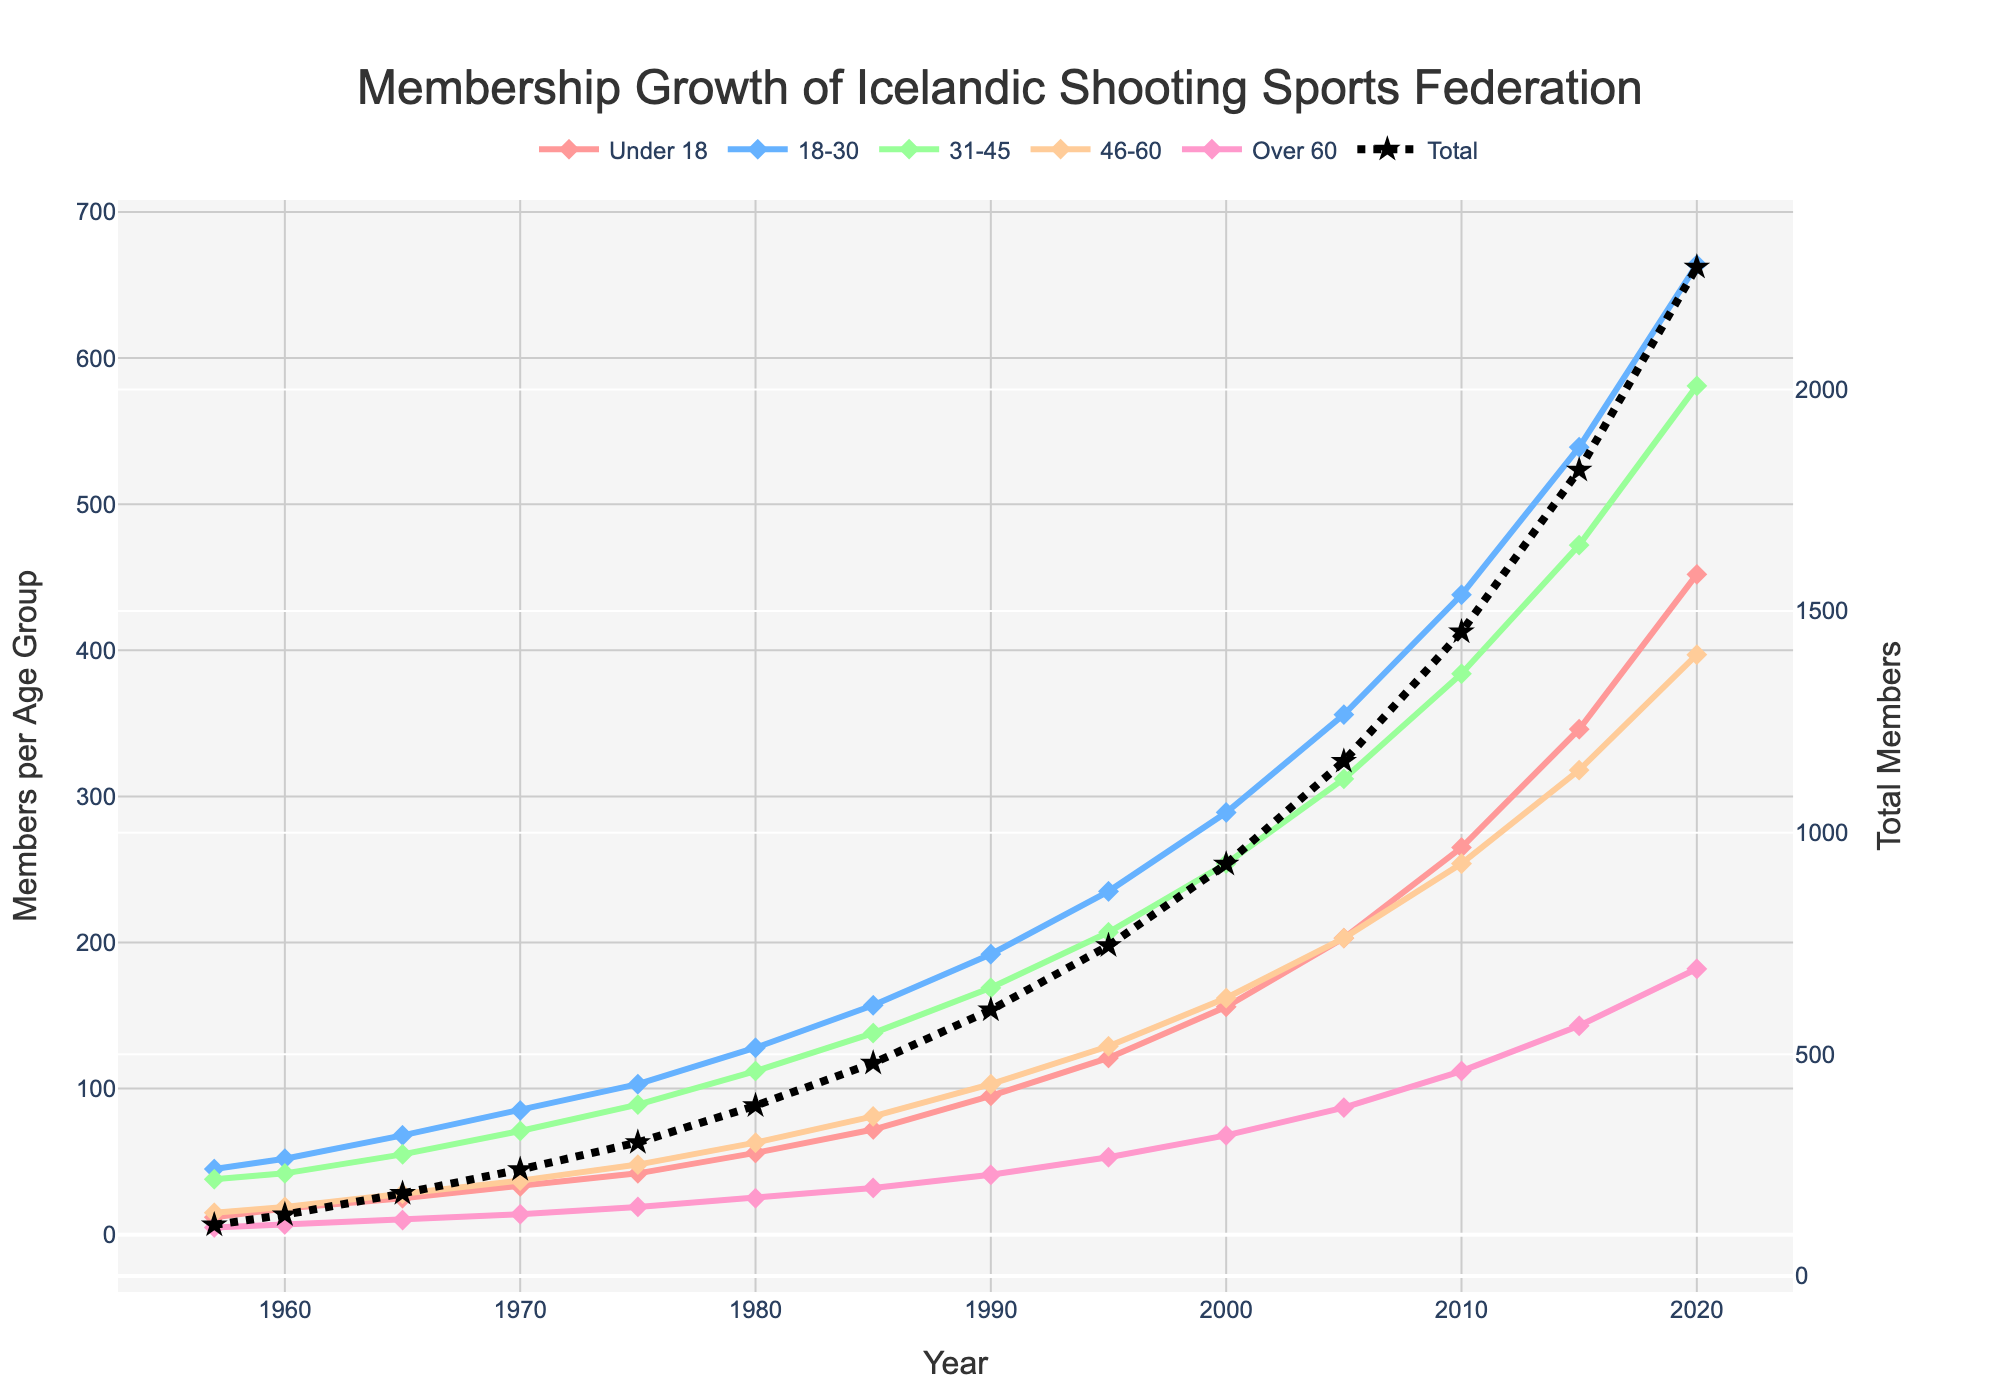Which age group had the most significant membership increase between 2015 and 2020? To determine the most significant membership increase, subtract the 2015 values from the 2020 values for each age group and find the largest difference. The increases are: Under 18: 452-346 = 106, 18-30: 664-539 = 125, 31-45: 581-472 = 109, 46-60: 397-318 = 79, Over 60: 182-143 = 39.
Answer: 18-30 What was the total membership in 1980? Sum the number of members in each age group in the year 1980: 56 (Under 18) + 128 (18-30) + 112 (31-45) + 63 (46-60) + 25 (Over 60) = 384.
Answer: 384 Did the Under 18 age group always maintain a steady increase in membership over the years? Examine the line representing the Under 18 age group from 1957 to 2020. The line consistently moves upwards without any declines, indicating a steady increase.
Answer: Yes Which year did the Over 60 age group surpass 100 members? Track the Over 60 line to see where it first exceeds 100 members; it achieves over 100 in the year 2010 with 112 members.
Answer: 2010 How did the total membership change between 1957 and 2020? Calculate the total membership for both years and find the difference: 1957 total = 12 + 45 + 38 + 15 + 5 = 115, 2020 total = 452 + 664 + 581 + 397 + 182 = 2276. The increase is 2276 - 115 = 2161.
Answer: 2161 Which age group had the smallest absolute growth in members between 1957 and 2020? Find the difference in members for each group between these years and identify the smallest change: Under 18: 452-12 = 440, 18-30: 664-45 = 619, 31-45: 581-38 = 543, 46-60: 397-15 = 382, Over 60: 182-5 = 177. The smallest increase is in the Over 60 group with 177.
Answer: Over 60 In which decade did the 18-30 age group see the highest membership growth? Calculate the growth for each decade by subtracting the start year from the end year across each decade (1960-1969, 1970-1979, etc.). The highest growth occurs between 2010 and 2020: 664 - 539 = 125.
Answer: 2010-2020 How many age groups had more than 300 members by 2020? Check the membership values for each age group in 2020 and count how many exceed 300: 452 (Under 18), 664 (18-30), 581 (31-45), 397 (46-60). Four age groups had more than 300 members.
Answer: Four 